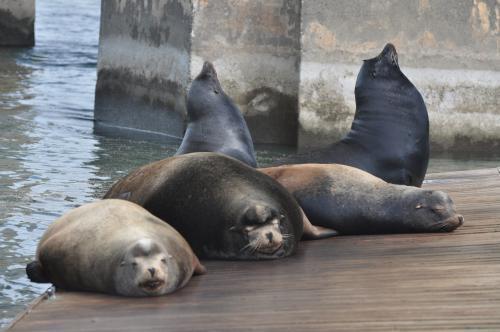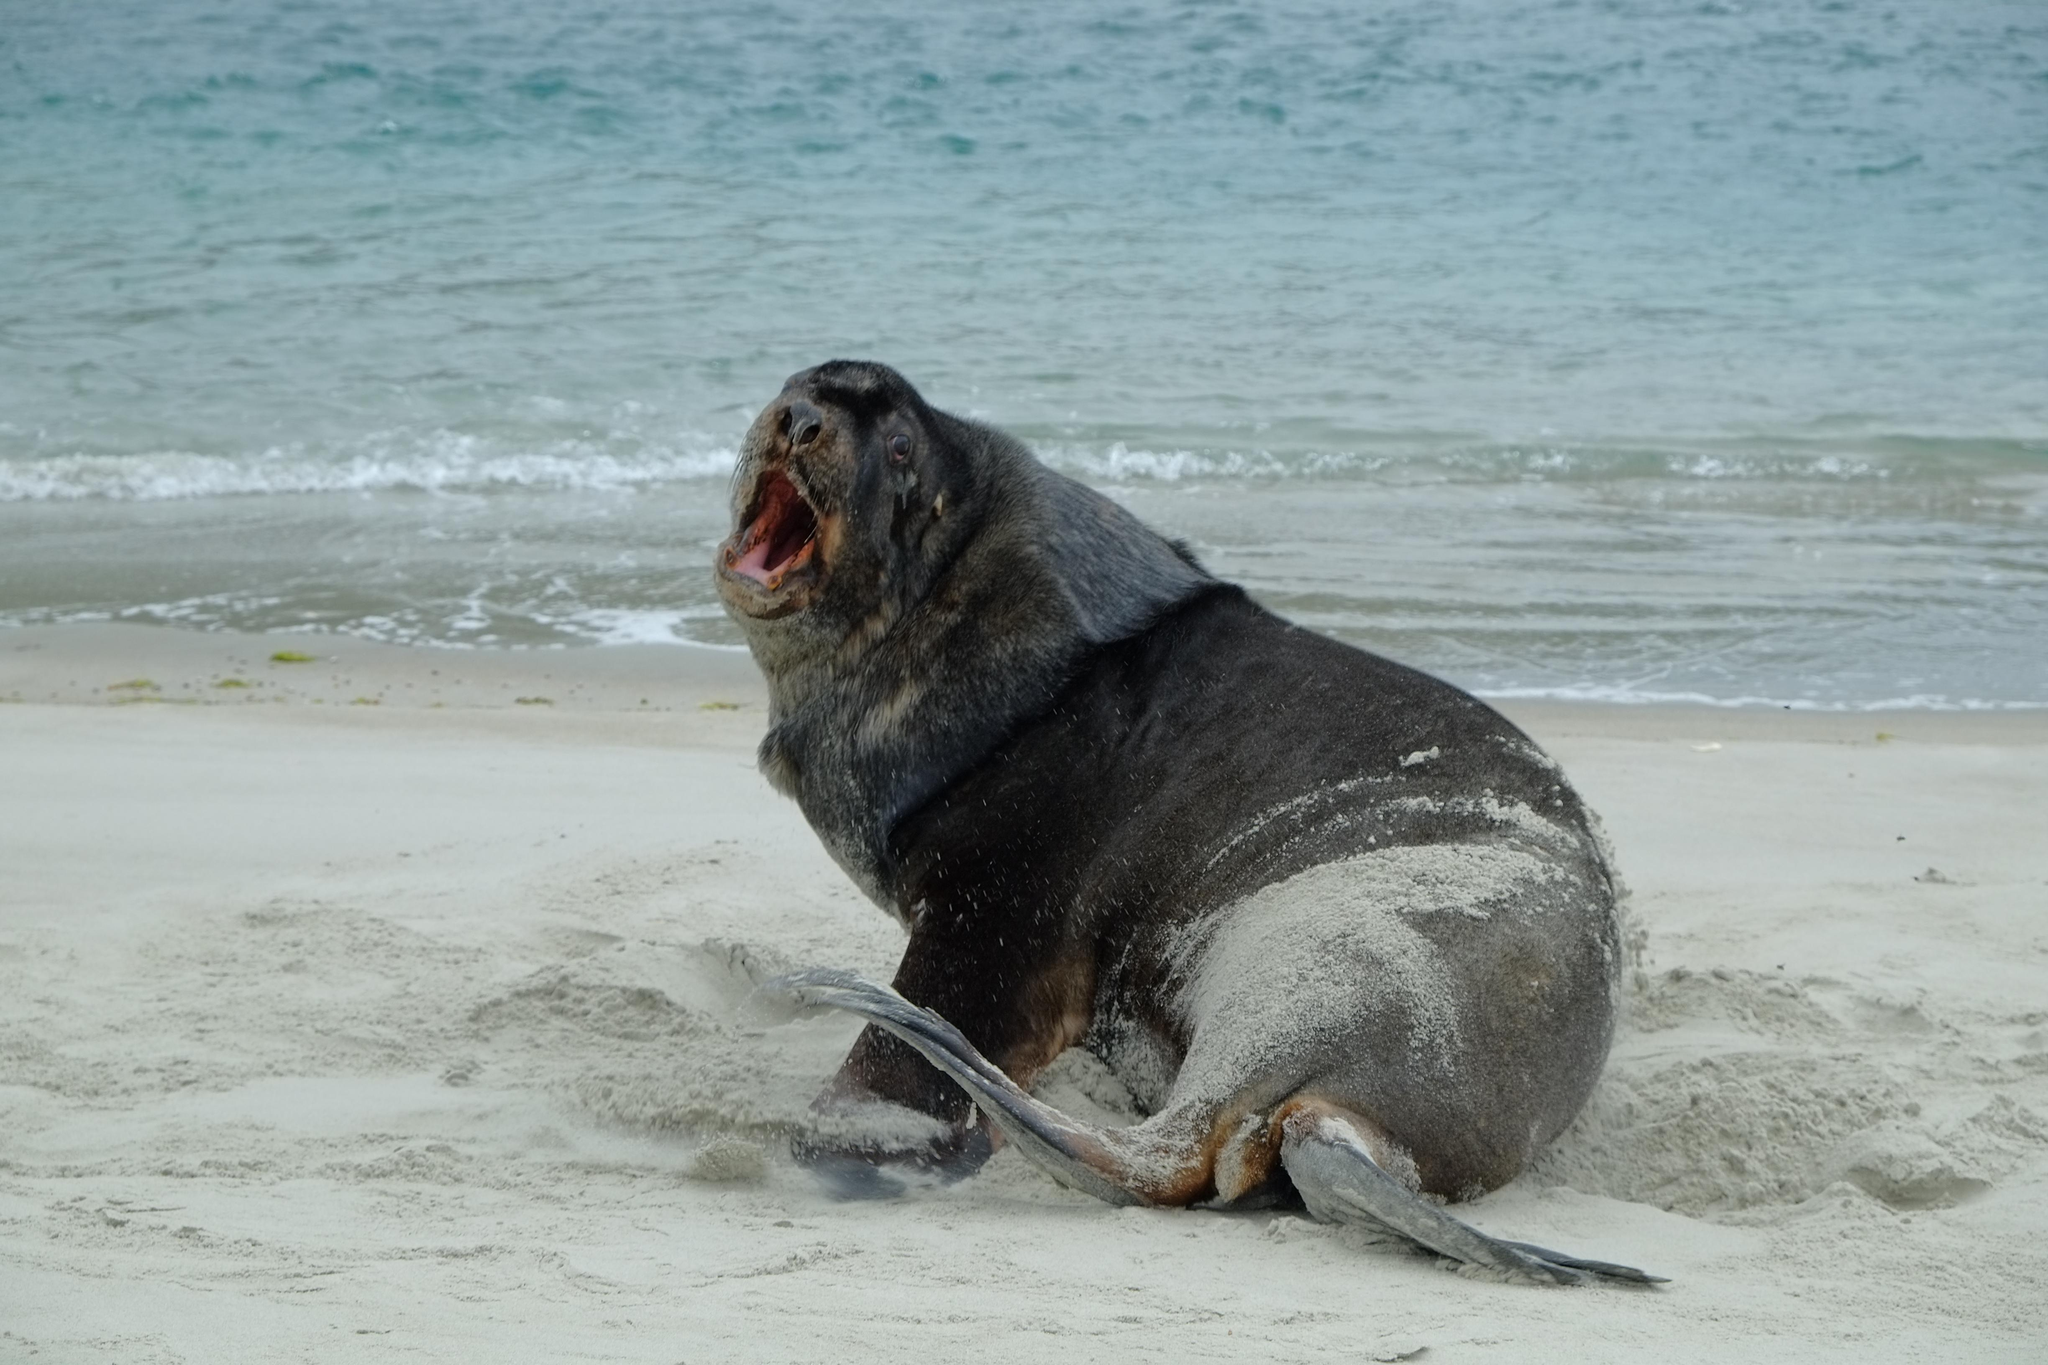The first image is the image on the left, the second image is the image on the right. For the images shown, is this caption "A seal is catching a fish." true? Answer yes or no. No. The first image is the image on the left, the second image is the image on the right. For the images shown, is this caption "The right image contains no more than one seal." true? Answer yes or no. Yes. 